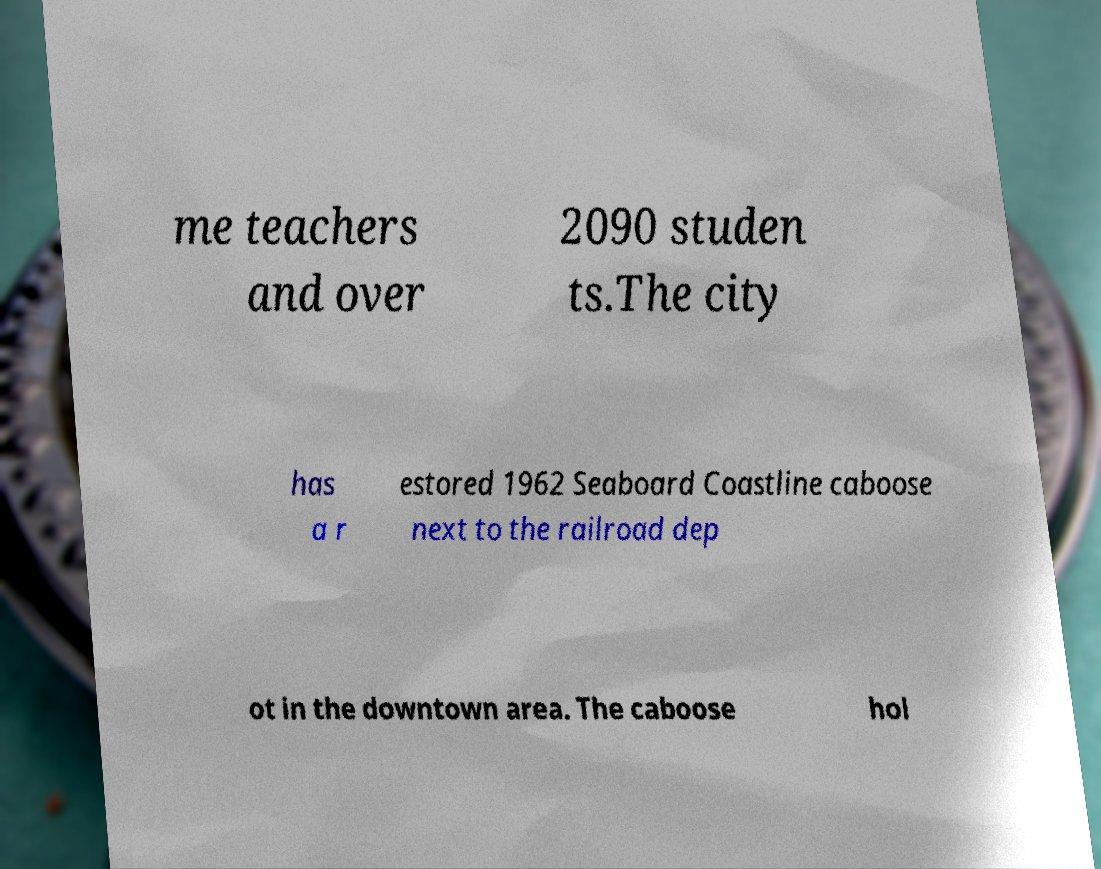Please identify and transcribe the text found in this image. me teachers and over 2090 studen ts.The city has a r estored 1962 Seaboard Coastline caboose next to the railroad dep ot in the downtown area. The caboose hol 